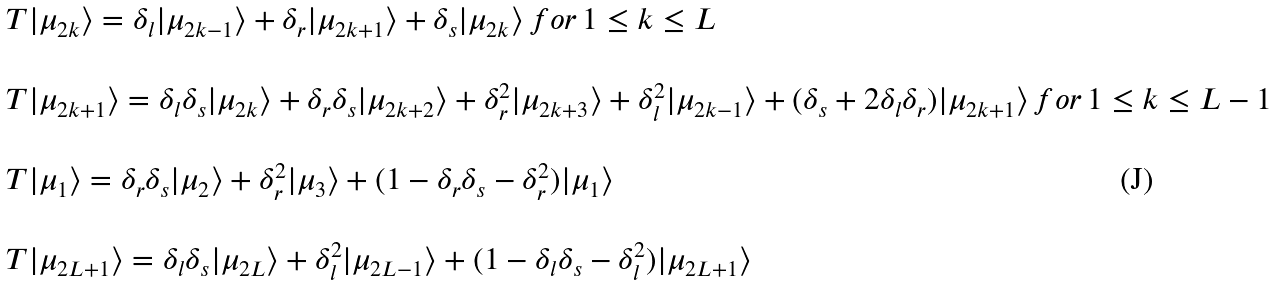<formula> <loc_0><loc_0><loc_500><loc_500>\begin{array} { l } T | \mu _ { 2 k } \rangle = \delta _ { l } | \mu _ { 2 k - 1 } \rangle + \delta _ { r } | \mu _ { 2 k + 1 } \rangle + \delta _ { s } | \mu _ { 2 k } \rangle \, f o r \, 1 \leq k \leq L \\ \\ T | \mu _ { 2 k + 1 } \rangle = \delta _ { l } \delta _ { s } | \mu _ { 2 k } \rangle + \delta _ { r } \delta _ { s } | \mu _ { 2 k + 2 } \rangle + \delta _ { r } ^ { 2 } | \mu _ { 2 k + 3 } \rangle + \delta _ { l } ^ { 2 } | \mu _ { 2 k - 1 } \rangle + ( \delta _ { s } + 2 \delta _ { l } \delta _ { r } ) | \mu _ { 2 k + 1 } \rangle \, f o r \, 1 \leq k \leq L - 1 \\ \\ T | \mu _ { 1 } \rangle = \delta _ { r } \delta _ { s } | \mu _ { 2 } \rangle + \delta _ { r } ^ { 2 } | \mu _ { 3 } \rangle + ( 1 - \delta _ { r } \delta _ { s } - \delta _ { r } ^ { 2 } ) | \mu _ { 1 } \rangle \\ \\ T | \mu _ { 2 L + 1 } \rangle = \delta _ { l } \delta _ { s } | \mu _ { 2 L } \rangle + \delta _ { l } ^ { 2 } | \mu _ { 2 L - 1 } \rangle + ( 1 - \delta _ { l } \delta _ { s } - \delta _ { l } ^ { 2 } ) | \mu _ { 2 L + 1 } \rangle \end{array}</formula> 